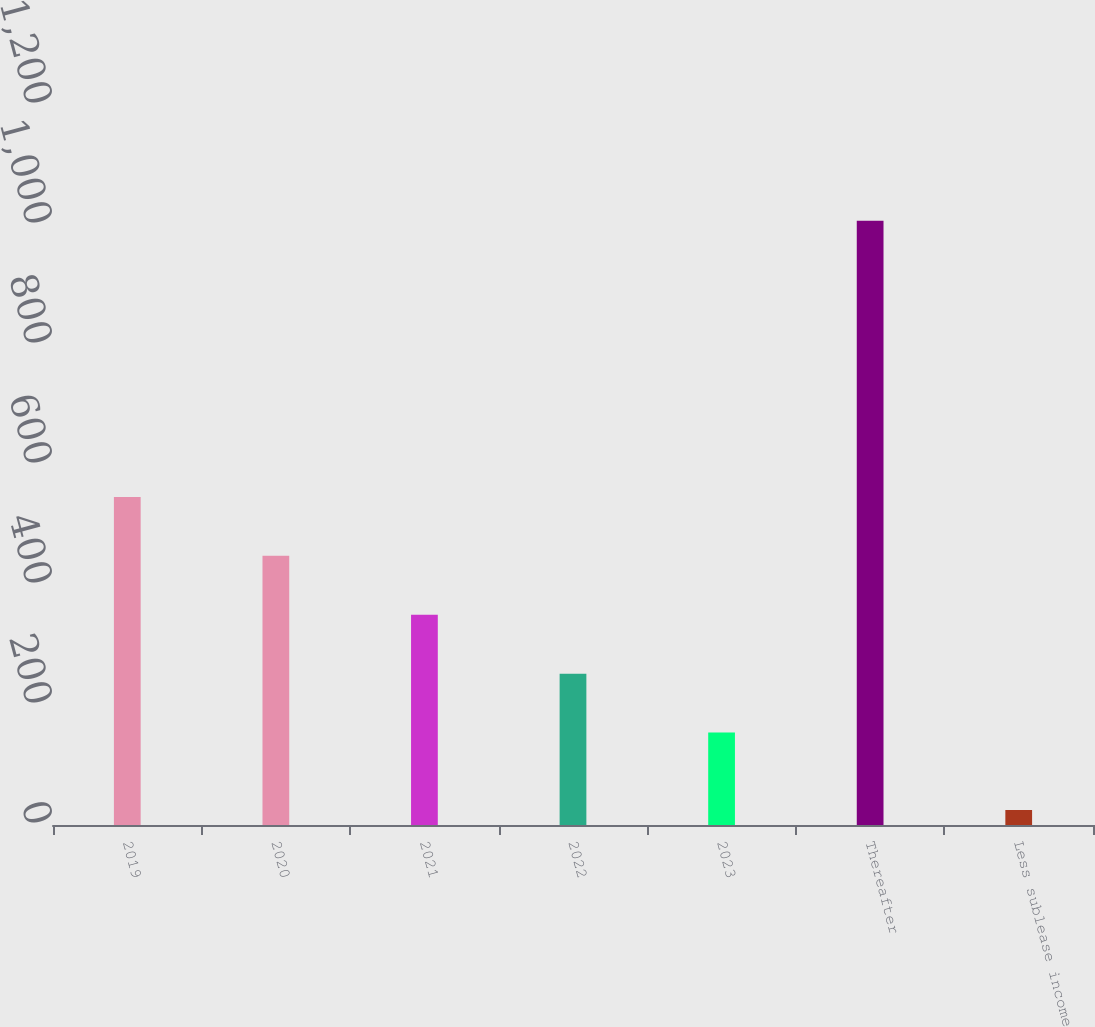<chart> <loc_0><loc_0><loc_500><loc_500><bar_chart><fcel>2019<fcel>2020<fcel>2021<fcel>2022<fcel>2023<fcel>Thereafter<fcel>Less sublease income<nl><fcel>546.8<fcel>448.6<fcel>350.4<fcel>252.2<fcel>154<fcel>1007<fcel>25<nl></chart> 